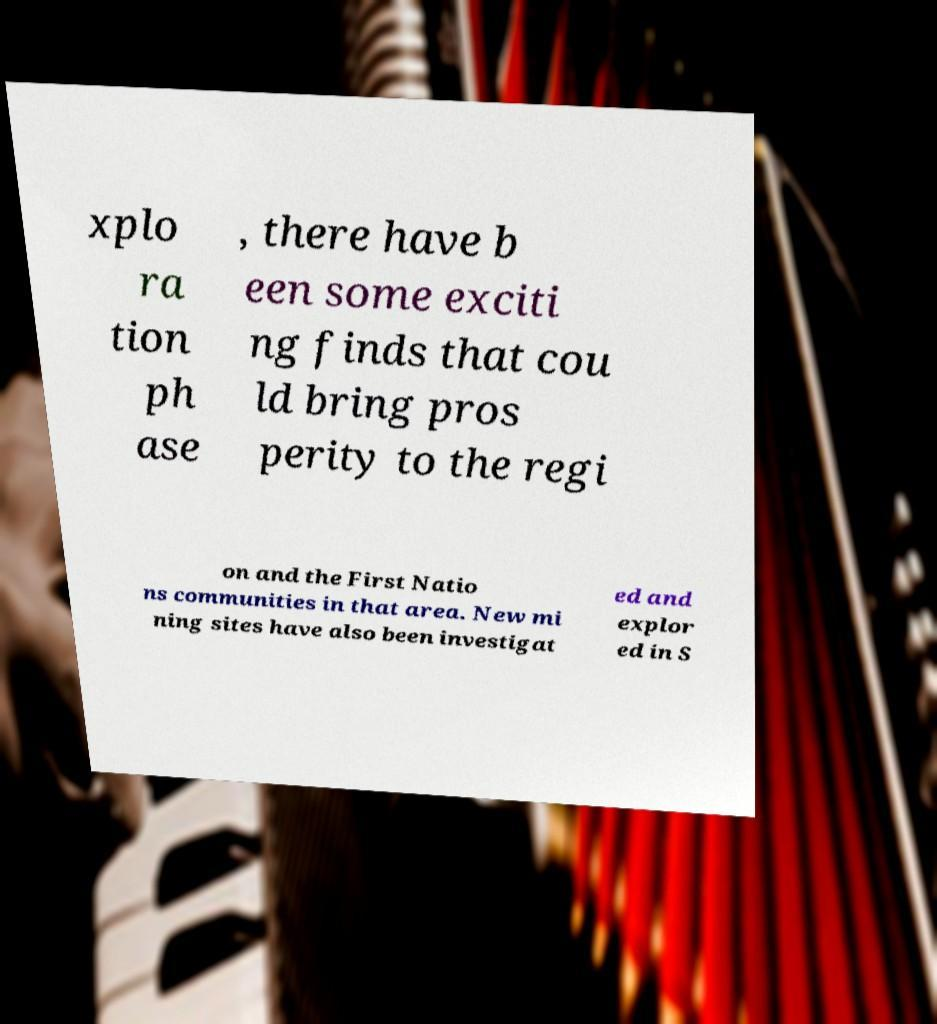There's text embedded in this image that I need extracted. Can you transcribe it verbatim? xplo ra tion ph ase , there have b een some exciti ng finds that cou ld bring pros perity to the regi on and the First Natio ns communities in that area. New mi ning sites have also been investigat ed and explor ed in S 